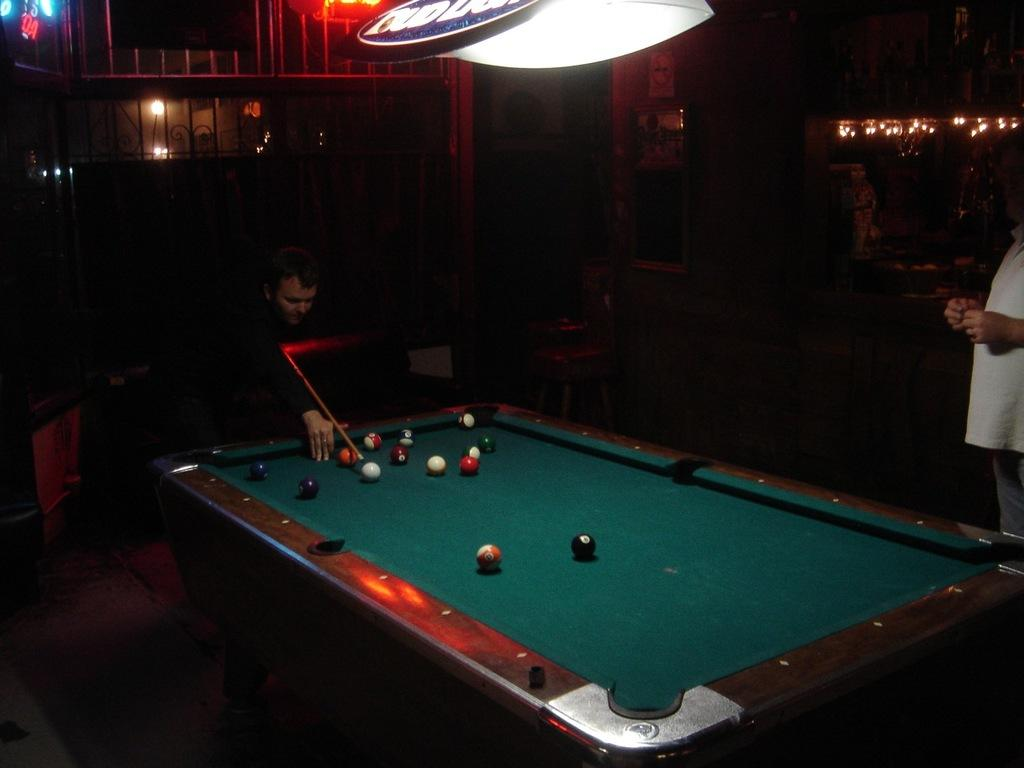What is the person in the image wearing? There is a person wearing a black dress in the image. What activity is the person in the black dress engaged in? The person is playing snooker. Can you describe the other person in the image? There is another person standing in the right corner of the image. Can you see any waves in the image? There are no waves present in the image. What type of mark can be seen on the snooker table in the image? The provided facts do not mention any specific marks on the snooker table. 